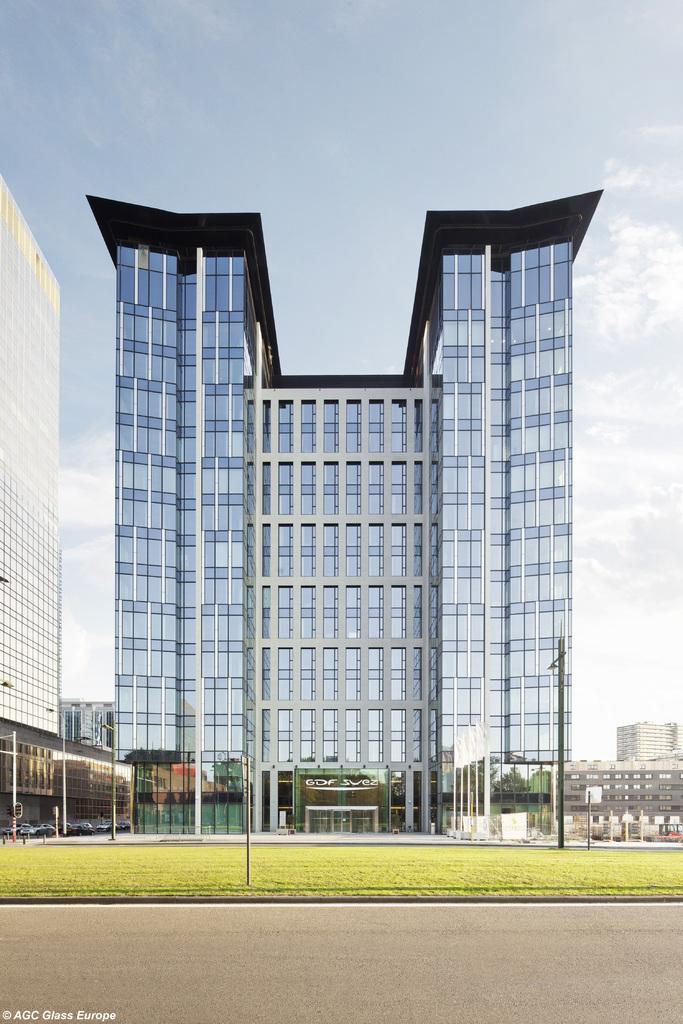Please provide a concise description of this image. This is an outside view. At the bottom there is a road. Beside the road, I can see the grass and there are some poles. In the background there are few buildings. At the top of the image I can see the sky. 